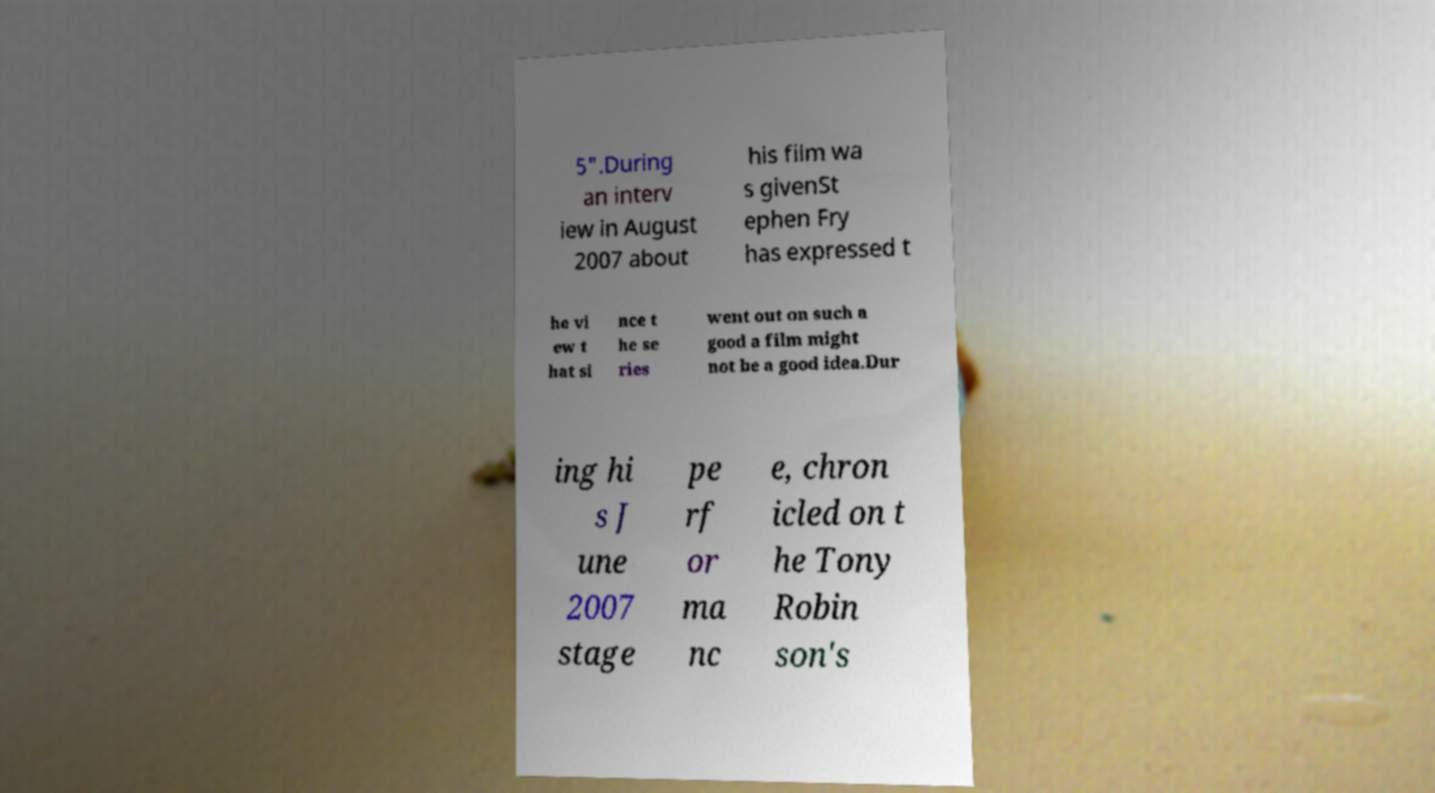For documentation purposes, I need the text within this image transcribed. Could you provide that? 5".During an interv iew in August 2007 about his film wa s givenSt ephen Fry has expressed t he vi ew t hat si nce t he se ries went out on such a good a film might not be a good idea.Dur ing hi s J une 2007 stage pe rf or ma nc e, chron icled on t he Tony Robin son's 